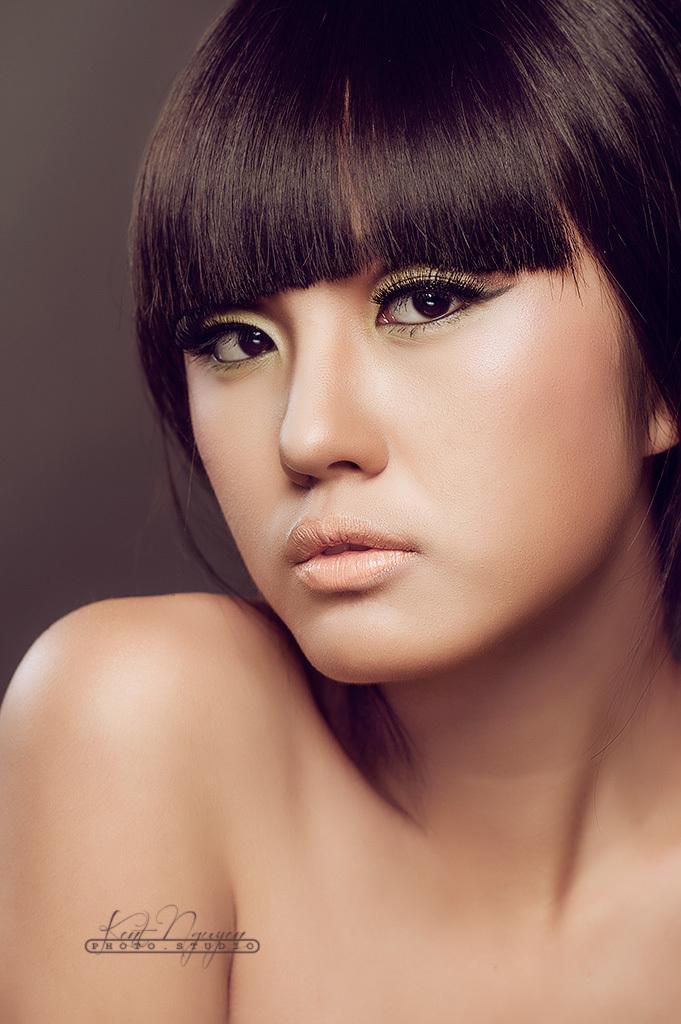Please provide a concise description of this image. In the picture there is a woman, she is posing for the photo. 